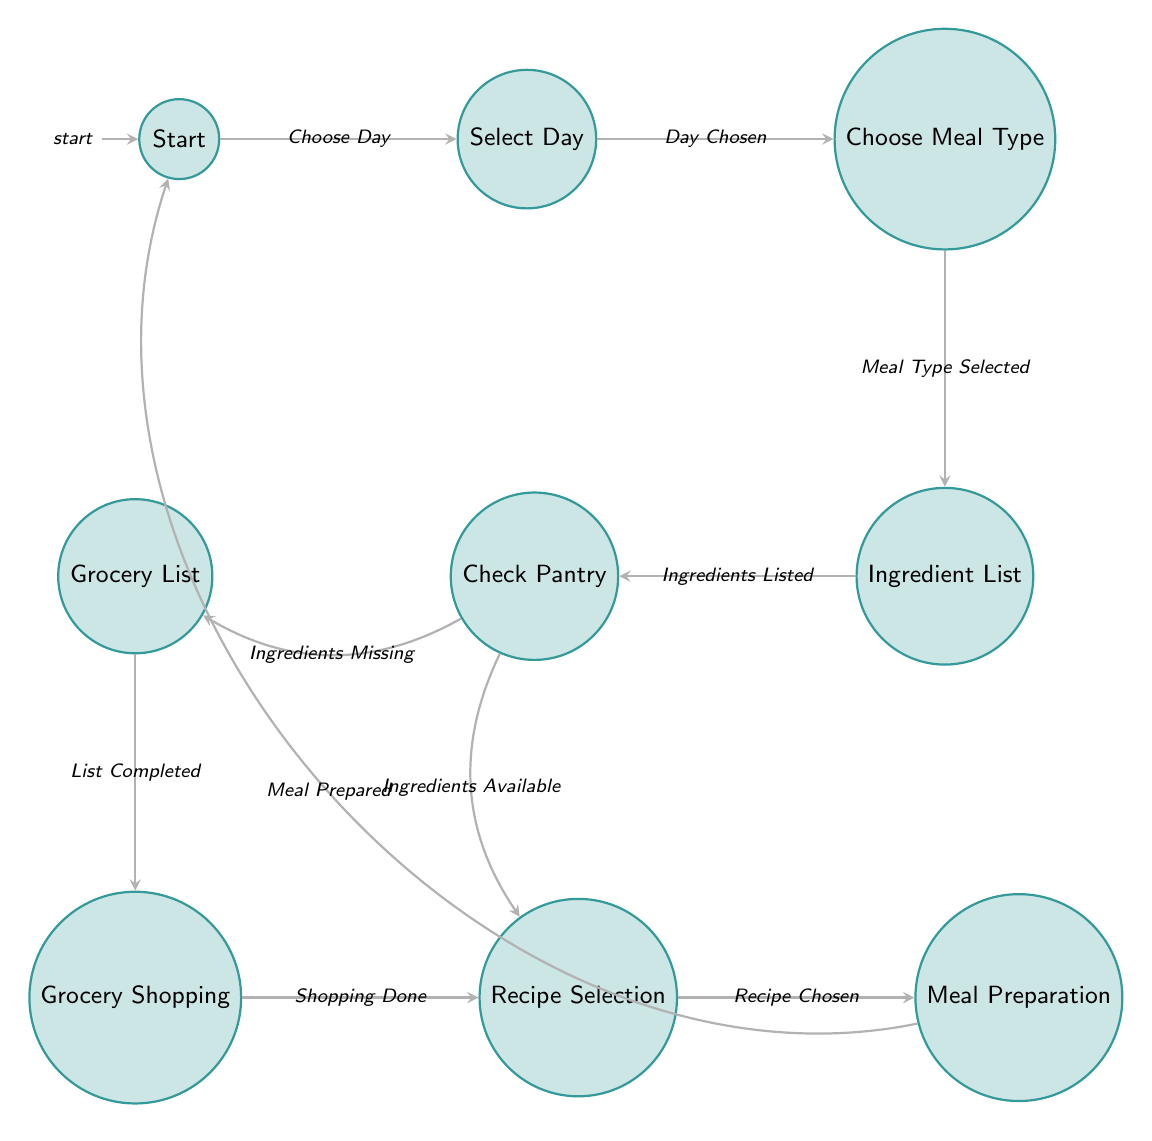What is the starting state of the meal planning process? The diagram indicates that the meal planning process begins at the "Start" state, which is the initial node.
Answer: Start How many states are there in the diagram? By counting the distinct states listed in the diagram, we find there are 8 states: Start, Select Day, Choose Meal Type, Ingredient List, Check Pantry, Grocery List, Grocery Shopping, and Recipe Selection.
Answer: 8 What is the action taken in the "Ingredient List" state? The action listed for the Ingredient List state is to "List ingredients needed for the meal," which specifies what occurs at that node.
Answer: List ingredients needed for the meal Which state do you transition to after choosing the meal type? After selecting the meal type, the next state to transition to is the "Ingredient List," as indicated by the arrow in the diagram connecting these two states.
Answer: Ingredient List What happens if ingredients are missing in the "Check Pantry" state? If ingredients are missing in the Check Pantry state, the transition leads to the "Grocery List" state, thus indicating that the next action is to create a grocery list.
Answer: Grocery List After preparing the meal, where do you go next? Upon meal preparation completion, the transition leads back to the "Start" state, indicating that the meal planning process may begin anew.
Answer: Start In the "Check Pantry" state, what are the possible transitions? There are two possible transitions from the Check Pantry state: one to "Recipe Selection" if the ingredients are available, and the other to "Grocery List" if the ingredients are missing. This defines the decision-making process at this node.
Answer: Recipe Selection and Grocery List What triggers the transition from "Grocery List" to "Grocery Shopping"? The transition from Grocery List to Grocery Shopping is triggered by the completion of the grocery list, specifically indicated as "List Completed" in the diagram.
Answer: List Completed What action occurs in the state "Recipe Selection"? In the Recipe Selection state, the action is to "Choose a specific recipe from a cookbook or online source," detailing what needs to be done at that point in the planning process.
Answer: Choose a specific recipe from a cookbook or online source 